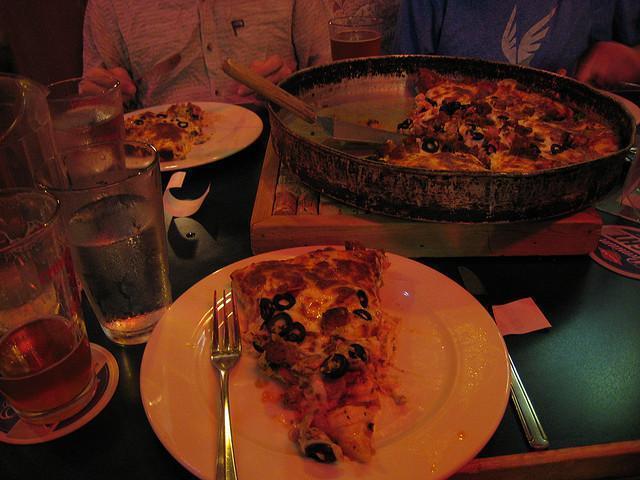What is on the pizza?
Select the correct answer and articulate reasoning with the following format: 'Answer: answer
Rationale: rationale.'
Options: Red peppers, sausages, olives, banana. Answer: olives.
Rationale: There are black objects on the pizza. 